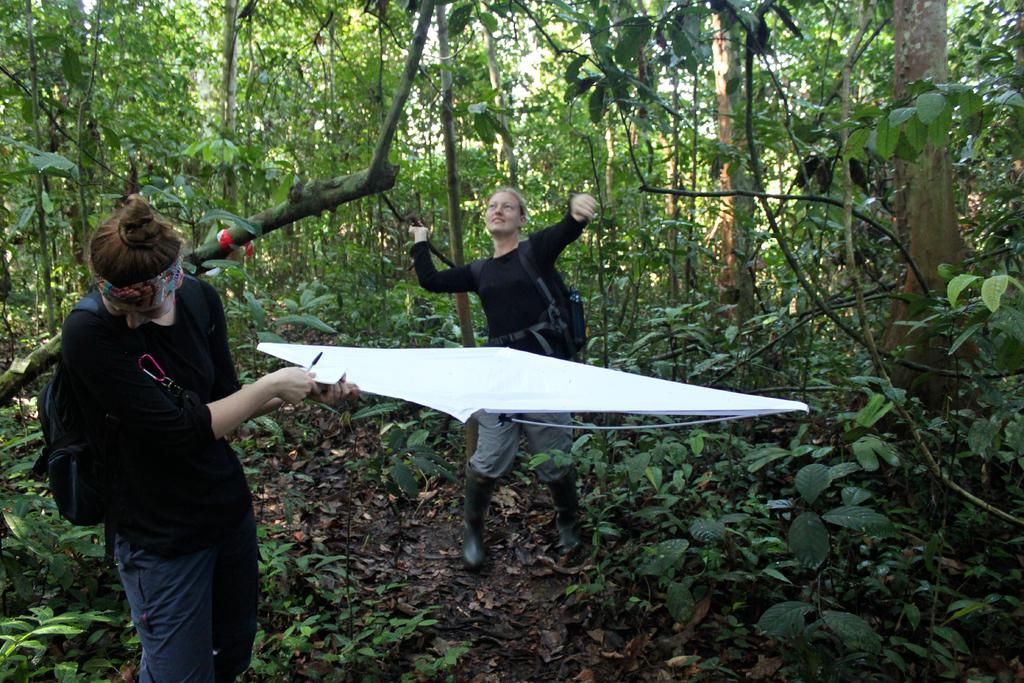How many people are in the image? There are two persons standing in the image. What are the persons holding in the image? The persons are holding objects. What type of vegetation can be seen in the image? There are plants in the image. What can be seen in the background of the image? There are trees and the sky visible in the background of the image. What type of crown is the person wearing in the image? There is no crown present in the image. What shape is the bead that the person is holding in the image? There is no bead present in the image. 